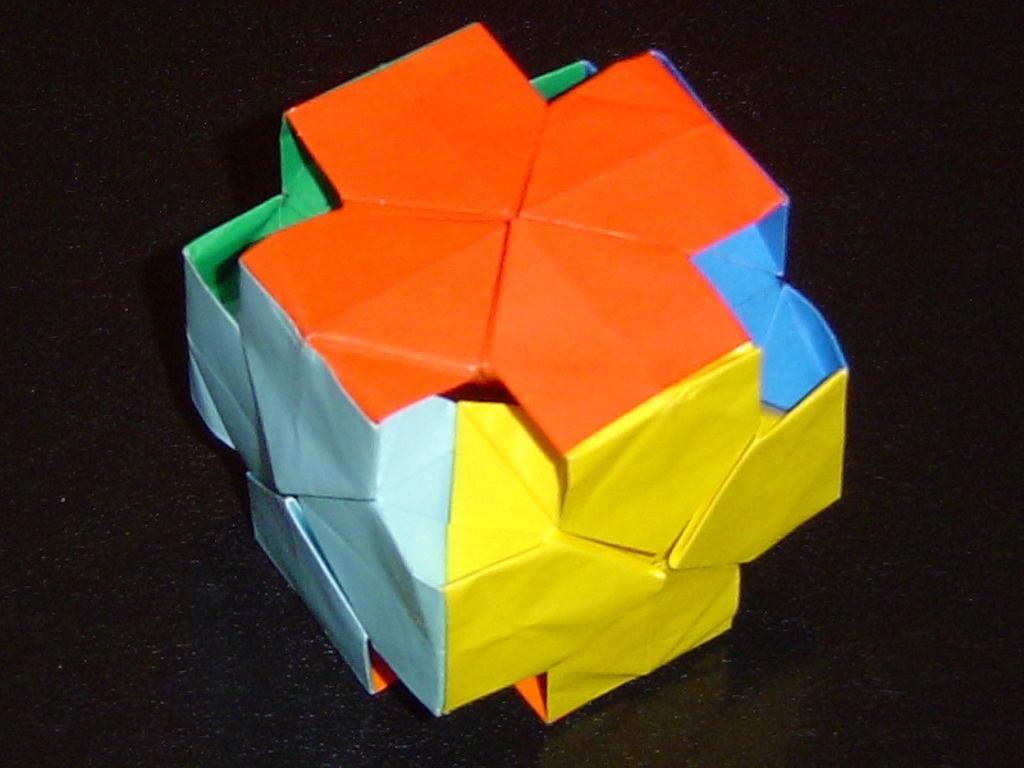Could you give a brief overview of what you see in this image? In this image there is an object , which is made up of colorful papers. 